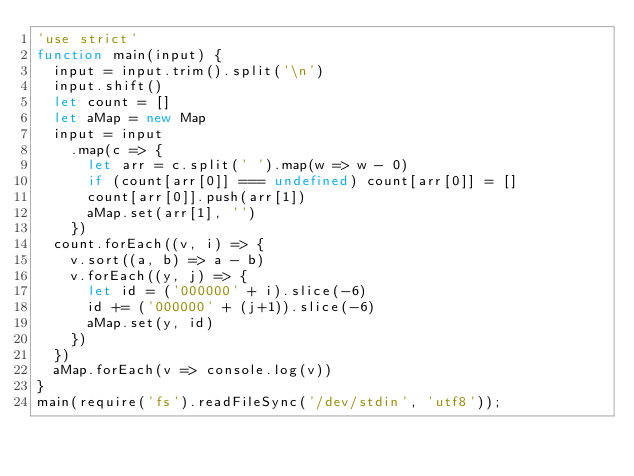Convert code to text. <code><loc_0><loc_0><loc_500><loc_500><_JavaScript_>'use strict'
function main(input) {
  input = input.trim().split('\n')
  input.shift()
  let count = []
  let aMap = new Map
  input = input
    .map(c => {
      let arr = c.split(' ').map(w => w - 0)
      if (count[arr[0]] === undefined) count[arr[0]] = []
      count[arr[0]].push(arr[1])
      aMap.set(arr[1], '')
    })
  count.forEach((v, i) => {
    v.sort((a, b) => a - b)
    v.forEach((y, j) => {
      let id = ('000000' + i).slice(-6)
      id += ('000000' + (j+1)).slice(-6)
      aMap.set(y, id)
    })
  })
  aMap.forEach(v => console.log(v))
}
main(require('fs').readFileSync('/dev/stdin', 'utf8'));
</code> 